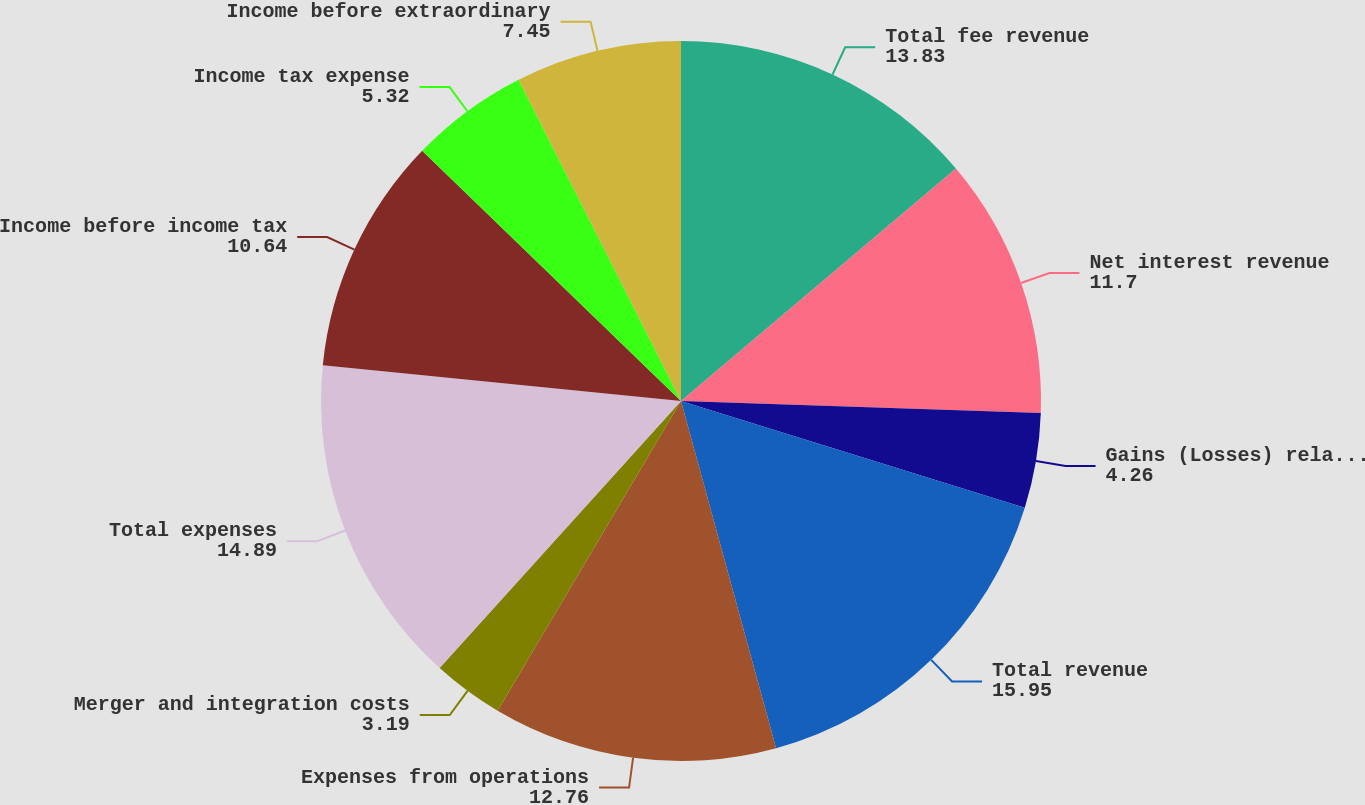Convert chart. <chart><loc_0><loc_0><loc_500><loc_500><pie_chart><fcel>Total fee revenue<fcel>Net interest revenue<fcel>Gains (Losses) related to<fcel>Total revenue<fcel>Expenses from operations<fcel>Merger and integration costs<fcel>Total expenses<fcel>Income before income tax<fcel>Income tax expense<fcel>Income before extraordinary<nl><fcel>13.83%<fcel>11.7%<fcel>4.26%<fcel>15.95%<fcel>12.76%<fcel>3.19%<fcel>14.89%<fcel>10.64%<fcel>5.32%<fcel>7.45%<nl></chart> 